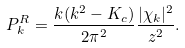<formula> <loc_0><loc_0><loc_500><loc_500>P _ { k } ^ { R } = \frac { k ( k ^ { 2 } - K _ { c } ) } { 2 \pi ^ { 2 } } \frac { | \chi _ { k } | ^ { 2 } } { z ^ { 2 } } .</formula> 